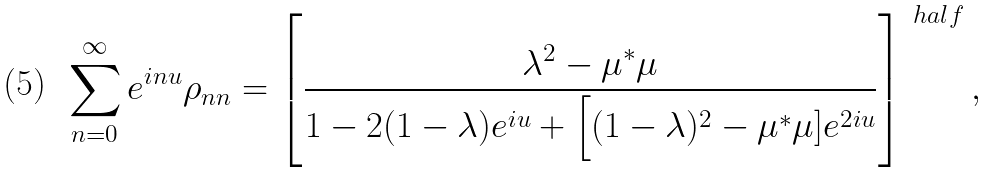<formula> <loc_0><loc_0><loc_500><loc_500>\sum _ { n = 0 } ^ { \infty } e ^ { i n u } \rho _ { n n } = \left [ \frac { \lambda ^ { 2 } - \mu ^ { * } \mu } { 1 - 2 ( 1 - \lambda ) e ^ { i u } + \Big [ ( 1 - \lambda ) ^ { 2 } - \mu ^ { * } \mu ] e ^ { 2 i u } } \right ] ^ { \ h a l f } ,</formula> 